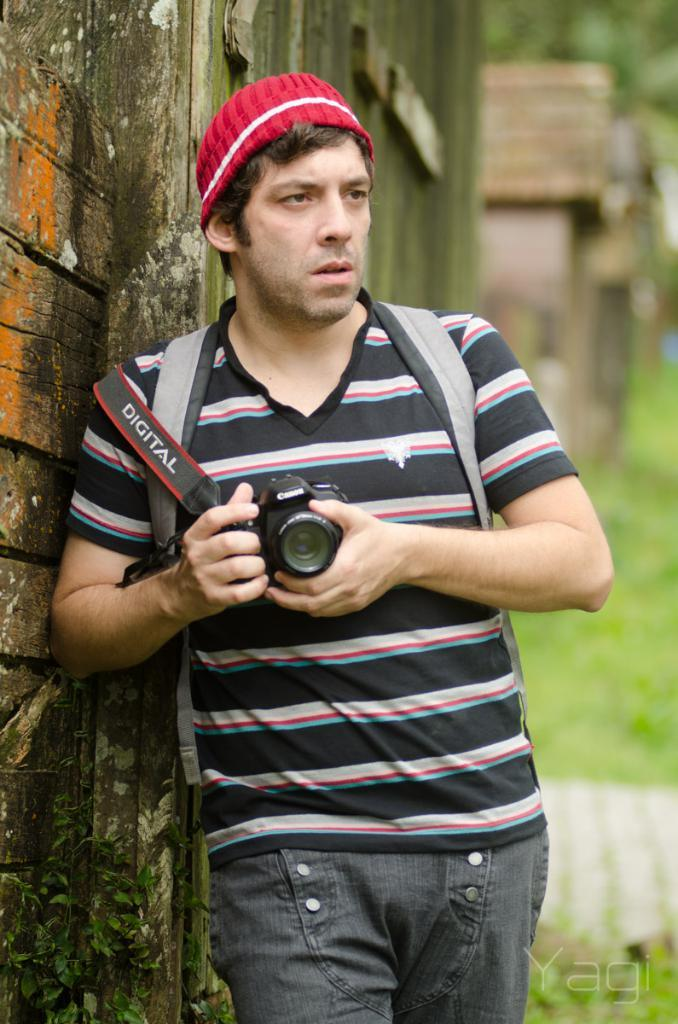Who is present in the image? There is a man in the image. What is the man wearing on his head? The man is wearing a red cap. What is the man holding in his hand? The man is holding a camera in his hand. What can be seen in the background of the image? There is a wall, grass, and houses in the background of the image. How is the background of the image depicted? The background is blurry. How many wax figures of the queen are present in the image? There are no wax figures or queens present in the image; it features a man holding a camera. 